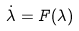Convert formula to latex. <formula><loc_0><loc_0><loc_500><loc_500>\dot { \lambda } = F ( \lambda )</formula> 